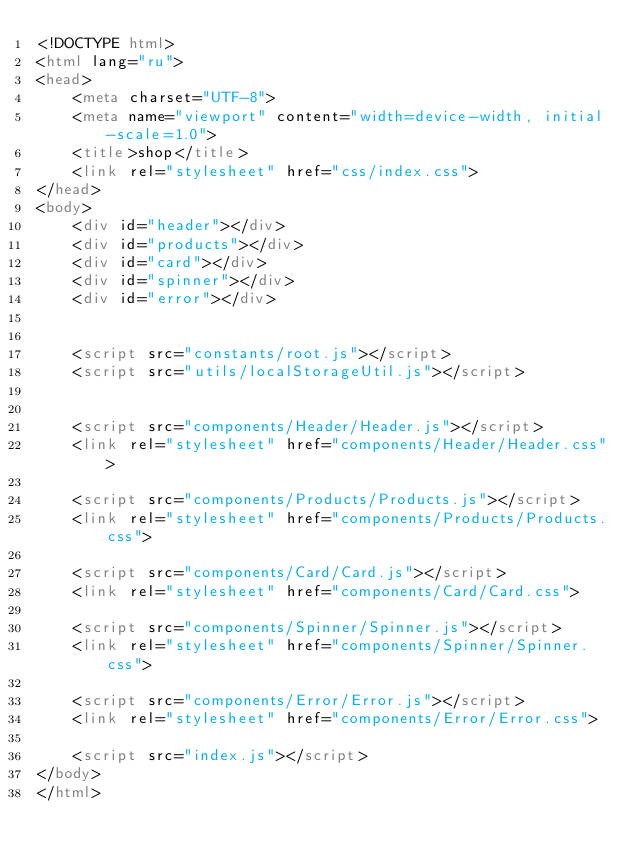<code> <loc_0><loc_0><loc_500><loc_500><_HTML_><!DOCTYPE html>
<html lang="ru">
<head>
    <meta charset="UTF-8">
    <meta name="viewport" content="width=device-width, initial-scale=1.0">
    <title>shop</title>
    <link rel="stylesheet" href="css/index.css">
</head>
<body>
    <div id="header"></div>
    <div id="products"></div>
    <div id="card"></div>
    <div id="spinner"></div>
    <div id="error"></div>
    

    <script src="constants/root.js"></script>
    <script src="utils/localStorageUtil.js"></script>


    <script src="components/Header/Header.js"></script>
    <link rel="stylesheet" href="components/Header/Header.css">

    <script src="components/Products/Products.js"></script>
    <link rel="stylesheet" href="components/Products/Products.css">

    <script src="components/Card/Card.js"></script>
    <link rel="stylesheet" href="components/Card/Card.css">

    <script src="components/Spinner/Spinner.js"></script>
    <link rel="stylesheet" href="components/Spinner/Spinner.css">

    <script src="components/Error/Error.js"></script>
    <link rel="stylesheet" href="components/Error/Error.css">

    <script src="index.js"></script>
</body>
</html></code> 